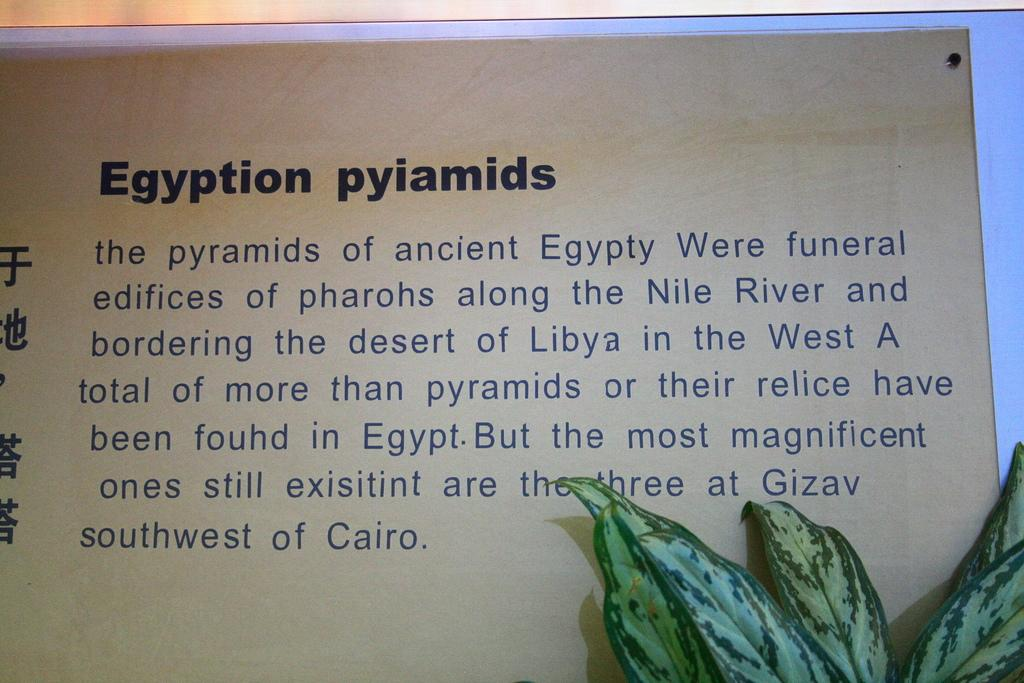<image>
Write a terse but informative summary of the picture. Egyption pyiamids signs about ancient Egypty and the Nile River. 